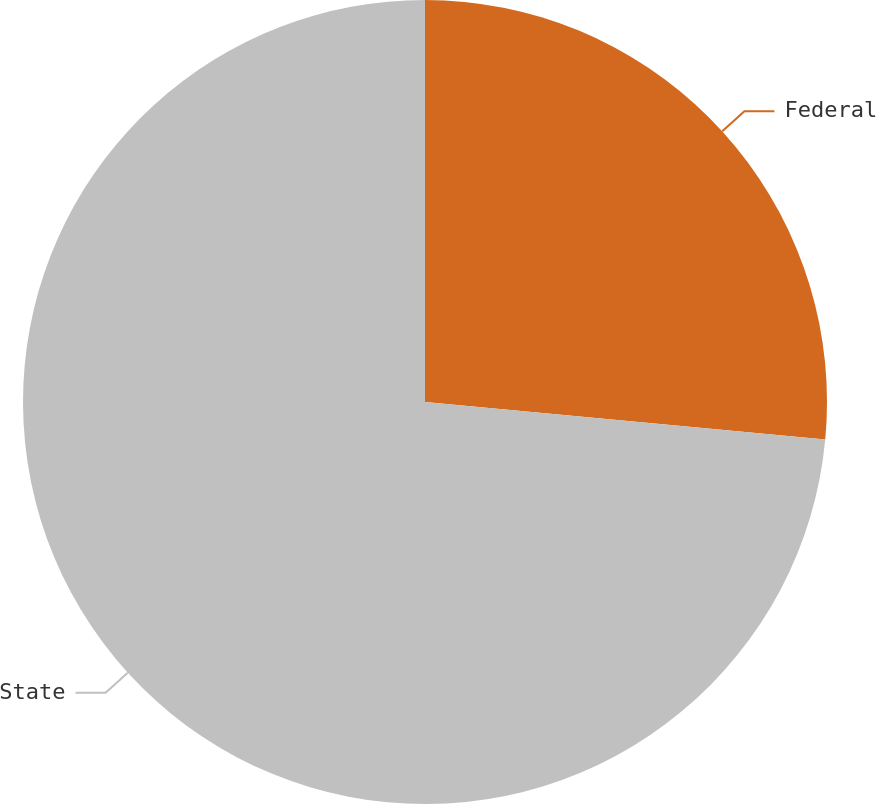<chart> <loc_0><loc_0><loc_500><loc_500><pie_chart><fcel>Federal<fcel>State<nl><fcel>26.49%<fcel>73.51%<nl></chart> 